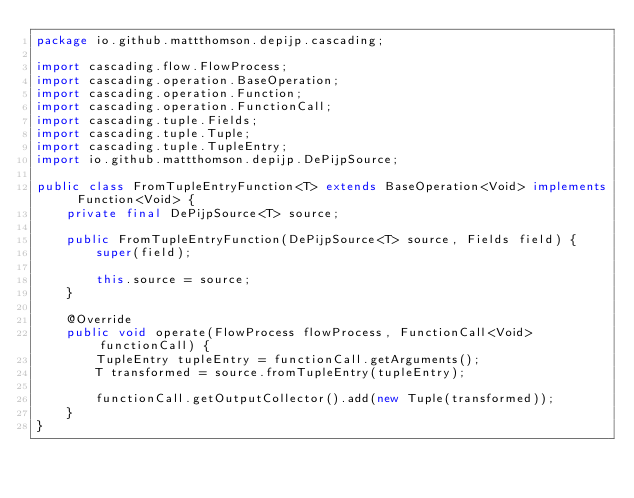Convert code to text. <code><loc_0><loc_0><loc_500><loc_500><_Java_>package io.github.mattthomson.depijp.cascading;

import cascading.flow.FlowProcess;
import cascading.operation.BaseOperation;
import cascading.operation.Function;
import cascading.operation.FunctionCall;
import cascading.tuple.Fields;
import cascading.tuple.Tuple;
import cascading.tuple.TupleEntry;
import io.github.mattthomson.depijp.DePijpSource;

public class FromTupleEntryFunction<T> extends BaseOperation<Void> implements Function<Void> {
    private final DePijpSource<T> source;

    public FromTupleEntryFunction(DePijpSource<T> source, Fields field) {
        super(field);

        this.source = source;
    }

    @Override
    public void operate(FlowProcess flowProcess, FunctionCall<Void> functionCall) {
        TupleEntry tupleEntry = functionCall.getArguments();
        T transformed = source.fromTupleEntry(tupleEntry);

        functionCall.getOutputCollector().add(new Tuple(transformed));
    }
}
</code> 